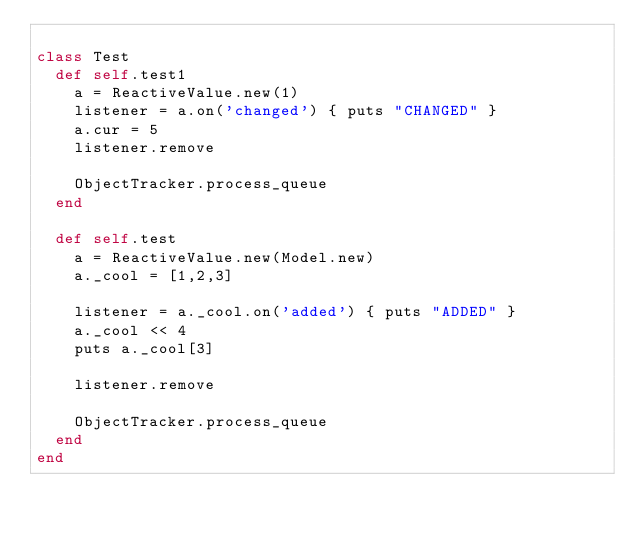Convert code to text. <code><loc_0><loc_0><loc_500><loc_500><_Ruby_>
class Test
  def self.test1
    a = ReactiveValue.new(1)
    listener = a.on('changed') { puts "CHANGED" }
    a.cur = 5
    listener.remove

    ObjectTracker.process_queue
  end

  def self.test
    a = ReactiveValue.new(Model.new)
    a._cool = [1,2,3]

    listener = a._cool.on('added') { puts "ADDED" }
    a._cool << 4
    puts a._cool[3]

    listener.remove

    ObjectTracker.process_queue
  end
end
</code> 